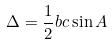Convert formula to latex. <formula><loc_0><loc_0><loc_500><loc_500>\Delta = \frac { 1 } { 2 } b c \sin A</formula> 